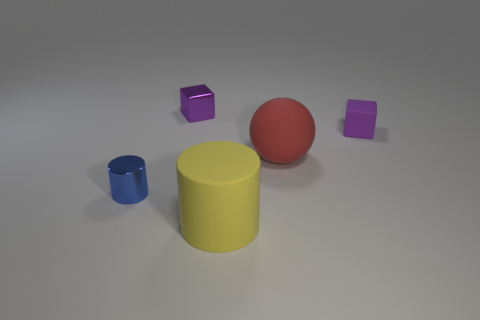There is a block that is to the left of the cylinder in front of the small blue shiny thing; what number of small purple objects are to the right of it?
Give a very brief answer. 1. There is another cube that is the same color as the tiny matte cube; what is its size?
Provide a short and direct response. Small. Is there a large thing that has the same material as the ball?
Offer a very short reply. Yes. Does the red ball have the same material as the big yellow cylinder?
Give a very brief answer. Yes. How many blue objects are in front of the metallic object that is in front of the red rubber object?
Your response must be concise. 0. How many blue objects are big rubber objects or small metal cylinders?
Offer a terse response. 1. The purple object in front of the small purple cube that is left of the large yellow matte object in front of the large sphere is what shape?
Provide a succinct answer. Cube. What color is the other rubber thing that is the same size as the red matte thing?
Your answer should be very brief. Yellow. How many small shiny objects have the same shape as the big yellow rubber object?
Your response must be concise. 1. There is a matte block; is its size the same as the purple block behind the small rubber cube?
Give a very brief answer. Yes. 